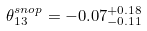Convert formula to latex. <formula><loc_0><loc_0><loc_500><loc_500>\theta ^ { s n o p } _ { 1 3 } = - 0 . 0 7 ^ { + 0 . 1 8 } _ { - 0 . 1 1 }</formula> 